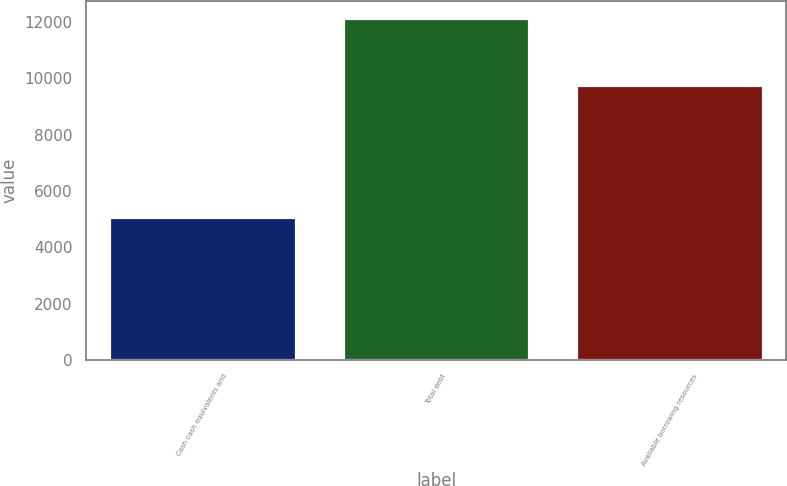Convert chart to OTSL. <chart><loc_0><loc_0><loc_500><loc_500><bar_chart><fcel>Cash cash equivalents and<fcel>Total debt<fcel>Available borrowing resources<nl><fcel>5084<fcel>12141<fcel>9757<nl></chart> 